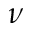Convert formula to latex. <formula><loc_0><loc_0><loc_500><loc_500>\nu</formula> 